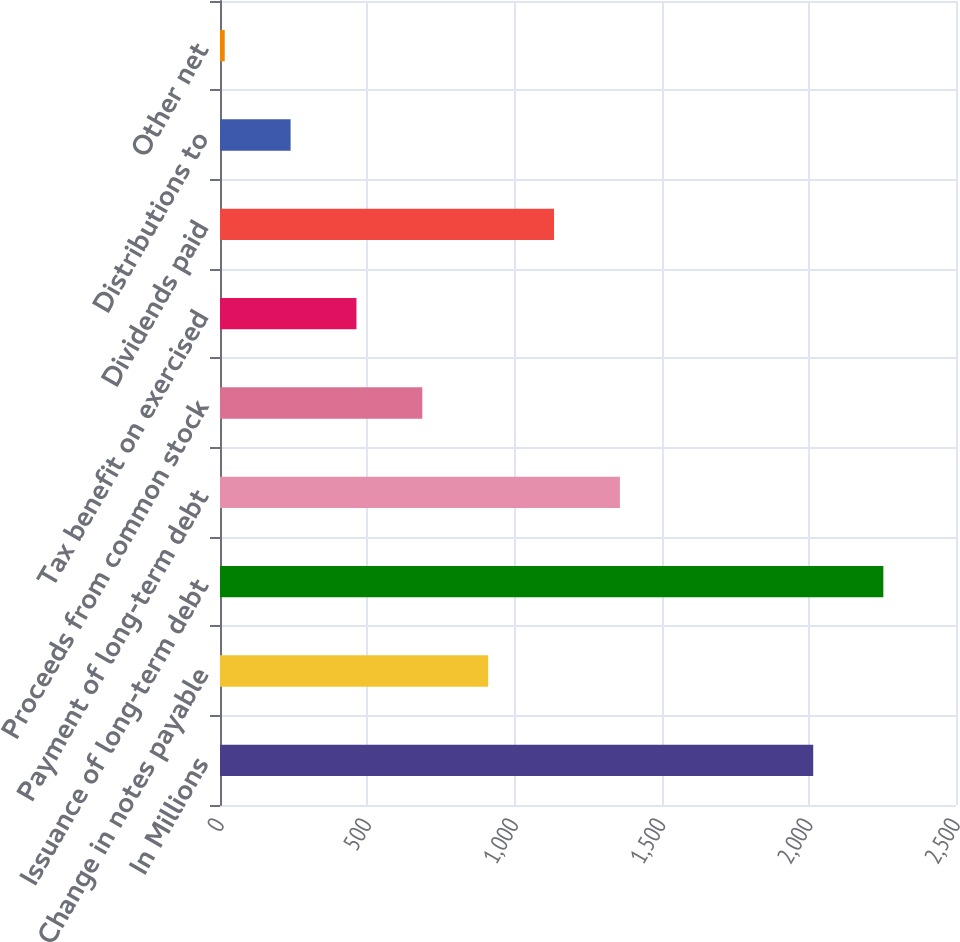<chart> <loc_0><loc_0><loc_500><loc_500><bar_chart><fcel>In Millions<fcel>Change in notes payable<fcel>Issuance of long-term debt<fcel>Payment of long-term debt<fcel>Proceeds from common stock<fcel>Tax benefit on exercised<fcel>Dividends paid<fcel>Distributions to<fcel>Other net<nl><fcel>2015<fcel>910.94<fcel>2253.2<fcel>1358.36<fcel>687.23<fcel>463.52<fcel>1134.65<fcel>239.81<fcel>16.1<nl></chart> 